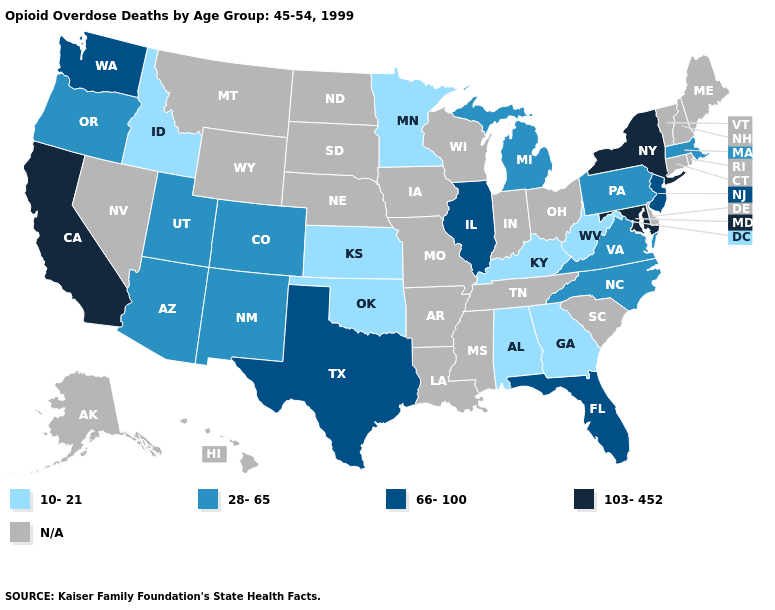Among the states that border New York , which have the lowest value?
Short answer required. Massachusetts, Pennsylvania. Does the first symbol in the legend represent the smallest category?
Quick response, please. Yes. What is the lowest value in the USA?
Short answer required. 10-21. What is the value of Wyoming?
Answer briefly. N/A. Among the states that border Colorado , which have the highest value?
Short answer required. Arizona, New Mexico, Utah. Name the states that have a value in the range N/A?
Concise answer only. Alaska, Arkansas, Connecticut, Delaware, Hawaii, Indiana, Iowa, Louisiana, Maine, Mississippi, Missouri, Montana, Nebraska, Nevada, New Hampshire, North Dakota, Ohio, Rhode Island, South Carolina, South Dakota, Tennessee, Vermont, Wisconsin, Wyoming. Is the legend a continuous bar?
Be succinct. No. Name the states that have a value in the range 66-100?
Answer briefly. Florida, Illinois, New Jersey, Texas, Washington. What is the value of Illinois?
Give a very brief answer. 66-100. What is the lowest value in the USA?
Answer briefly. 10-21. What is the value of Colorado?
Write a very short answer. 28-65. How many symbols are there in the legend?
Concise answer only. 5. Which states have the lowest value in the MidWest?
Keep it brief. Kansas, Minnesota. What is the value of New Jersey?
Answer briefly. 66-100. 